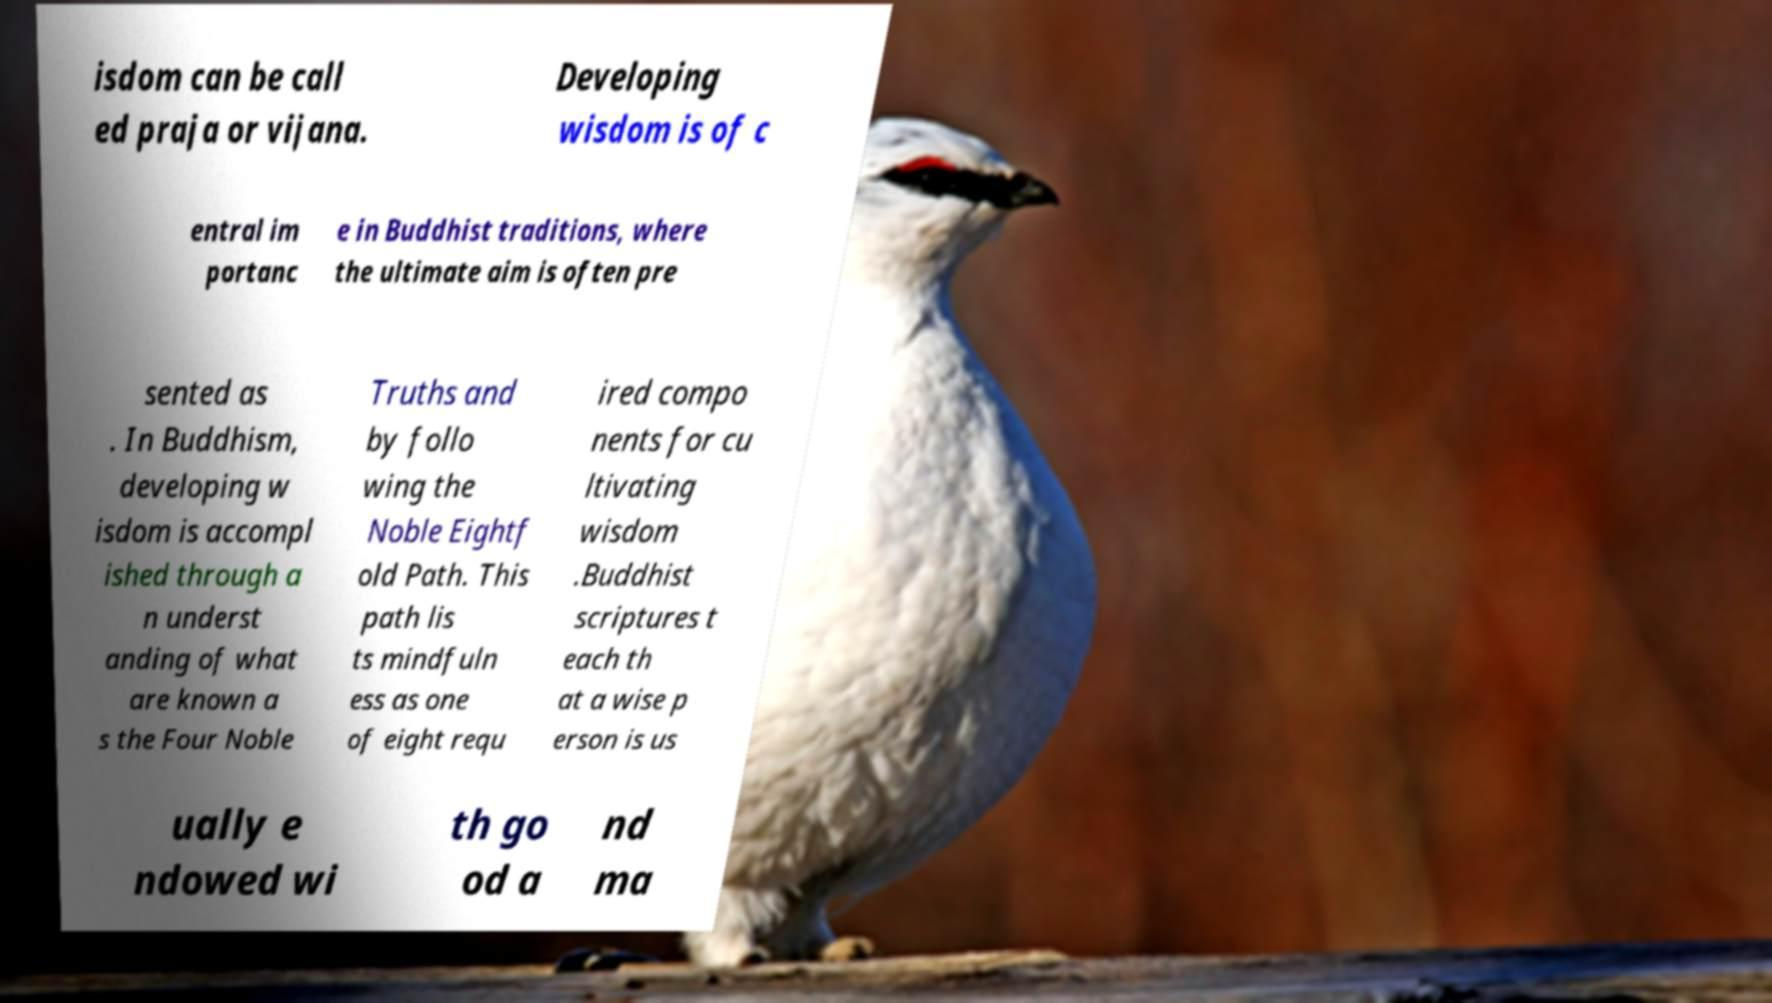Can you accurately transcribe the text from the provided image for me? isdom can be call ed praja or vijana. Developing wisdom is of c entral im portanc e in Buddhist traditions, where the ultimate aim is often pre sented as . In Buddhism, developing w isdom is accompl ished through a n underst anding of what are known a s the Four Noble Truths and by follo wing the Noble Eightf old Path. This path lis ts mindfuln ess as one of eight requ ired compo nents for cu ltivating wisdom .Buddhist scriptures t each th at a wise p erson is us ually e ndowed wi th go od a nd ma 